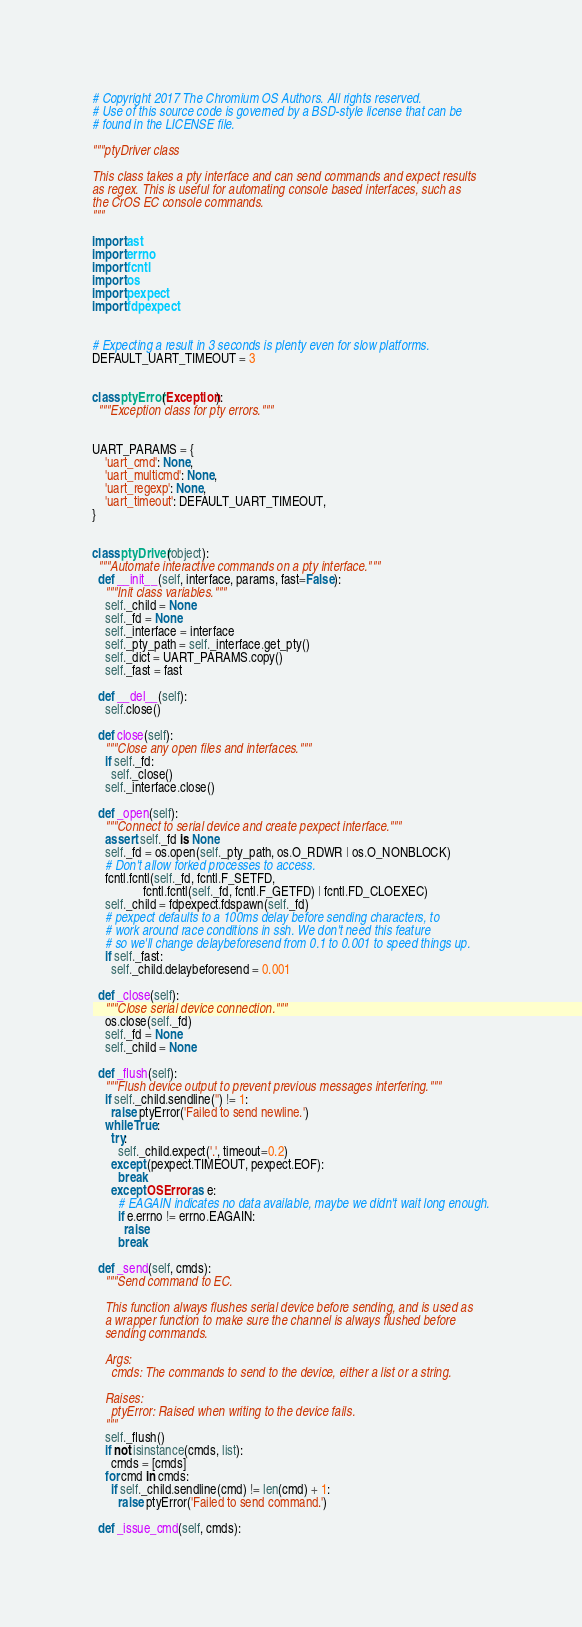Convert code to text. <code><loc_0><loc_0><loc_500><loc_500><_Python_># Copyright 2017 The Chromium OS Authors. All rights reserved.
# Use of this source code is governed by a BSD-style license that can be
# found in the LICENSE file.

"""ptyDriver class

This class takes a pty interface and can send commands and expect results
as regex. This is useful for automating console based interfaces, such as
the CrOS EC console commands.
"""

import ast
import errno
import fcntl
import os
import pexpect
import fdpexpect


# Expecting a result in 3 seconds is plenty even for slow platforms.
DEFAULT_UART_TIMEOUT = 3


class ptyError(Exception):
  """Exception class for pty errors."""


UART_PARAMS = {
    'uart_cmd': None,
    'uart_multicmd': None,
    'uart_regexp': None,
    'uart_timeout': DEFAULT_UART_TIMEOUT,
}


class ptyDriver(object):
  """Automate interactive commands on a pty interface."""
  def __init__(self, interface, params, fast=False):
    """Init class variables."""
    self._child = None
    self._fd = None
    self._interface = interface
    self._pty_path = self._interface.get_pty()
    self._dict = UART_PARAMS.copy()
    self._fast = fast

  def __del__(self):
    self.close()

  def close(self):
    """Close any open files and interfaces."""
    if self._fd:
      self._close()
    self._interface.close()

  def _open(self):
    """Connect to serial device and create pexpect interface."""
    assert self._fd is None
    self._fd = os.open(self._pty_path, os.O_RDWR | os.O_NONBLOCK)
    # Don't allow forked processes to access.
    fcntl.fcntl(self._fd, fcntl.F_SETFD,
                fcntl.fcntl(self._fd, fcntl.F_GETFD) | fcntl.FD_CLOEXEC)
    self._child = fdpexpect.fdspawn(self._fd)
    # pexpect defaults to a 100ms delay before sending characters, to
    # work around race conditions in ssh. We don't need this feature
    # so we'll change delaybeforesend from 0.1 to 0.001 to speed things up.
    if self._fast:
      self._child.delaybeforesend = 0.001

  def _close(self):
    """Close serial device connection."""
    os.close(self._fd)
    self._fd = None
    self._child = None

  def _flush(self):
    """Flush device output to prevent previous messages interfering."""
    if self._child.sendline('') != 1:
      raise ptyError('Failed to send newline.')
    while True:
      try:
        self._child.expect('.', timeout=0.2)
      except (pexpect.TIMEOUT, pexpect.EOF):
        break
      except OSError as e:
        # EAGAIN indicates no data available, maybe we didn't wait long enough.
        if e.errno != errno.EAGAIN:
          raise
        break

  def _send(self, cmds):
    """Send command to EC.

    This function always flushes serial device before sending, and is used as
    a wrapper function to make sure the channel is always flushed before
    sending commands.

    Args:
      cmds: The commands to send to the device, either a list or a string.

    Raises:
      ptyError: Raised when writing to the device fails.
    """
    self._flush()
    if not isinstance(cmds, list):
      cmds = [cmds]
    for cmd in cmds:
      if self._child.sendline(cmd) != len(cmd) + 1:
        raise ptyError('Failed to send command.')

  def _issue_cmd(self, cmds):</code> 